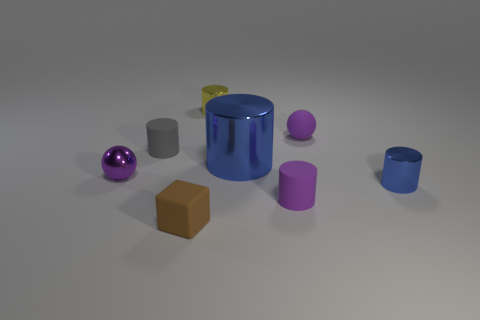Subtract all gray cylinders. How many cylinders are left? 4 Subtract all purple cylinders. How many cylinders are left? 4 Subtract all green cylinders. Subtract all brown cubes. How many cylinders are left? 5 Add 1 purple rubber cylinders. How many objects exist? 9 Subtract all blocks. How many objects are left? 7 Subtract 0 brown spheres. How many objects are left? 8 Subtract all rubber cylinders. Subtract all small gray cubes. How many objects are left? 6 Add 4 tiny purple things. How many tiny purple things are left? 7 Add 5 yellow metallic cylinders. How many yellow metallic cylinders exist? 6 